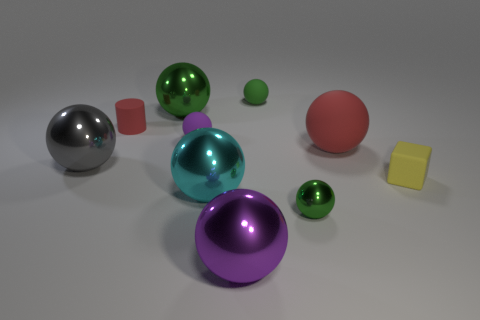How many green balls must be subtracted to get 1 green balls? 2 Subtract all red cylinders. How many green balls are left? 3 Subtract 5 spheres. How many spheres are left? 3 Subtract all red balls. How many balls are left? 7 Subtract all large gray metallic spheres. How many spheres are left? 7 Subtract all cyan spheres. Subtract all gray blocks. How many spheres are left? 7 Subtract all cylinders. How many objects are left? 9 Add 7 tiny green shiny spheres. How many tiny green shiny spheres are left? 8 Add 2 matte spheres. How many matte spheres exist? 5 Subtract 0 blue cylinders. How many objects are left? 10 